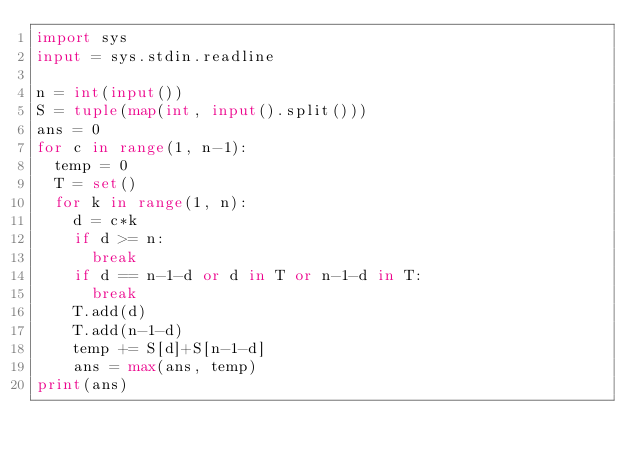<code> <loc_0><loc_0><loc_500><loc_500><_Python_>import sys
input = sys.stdin.readline

n = int(input())
S = tuple(map(int, input().split()))
ans = 0
for c in range(1, n-1):
  temp = 0
  T = set()
  for k in range(1, n):
    d = c*k
    if d >= n:
      break
    if d == n-1-d or d in T or n-1-d in T:
      break
    T.add(d)
    T.add(n-1-d)
    temp += S[d]+S[n-1-d]
    ans = max(ans, temp)
print(ans)</code> 